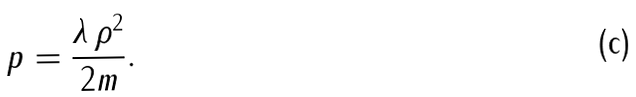Convert formula to latex. <formula><loc_0><loc_0><loc_500><loc_500>p = { \frac { \lambda \, \rho ^ { 2 } } { 2 m } } .</formula> 